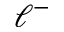<formula> <loc_0><loc_0><loc_500><loc_500>\ell ^ { - }</formula> 